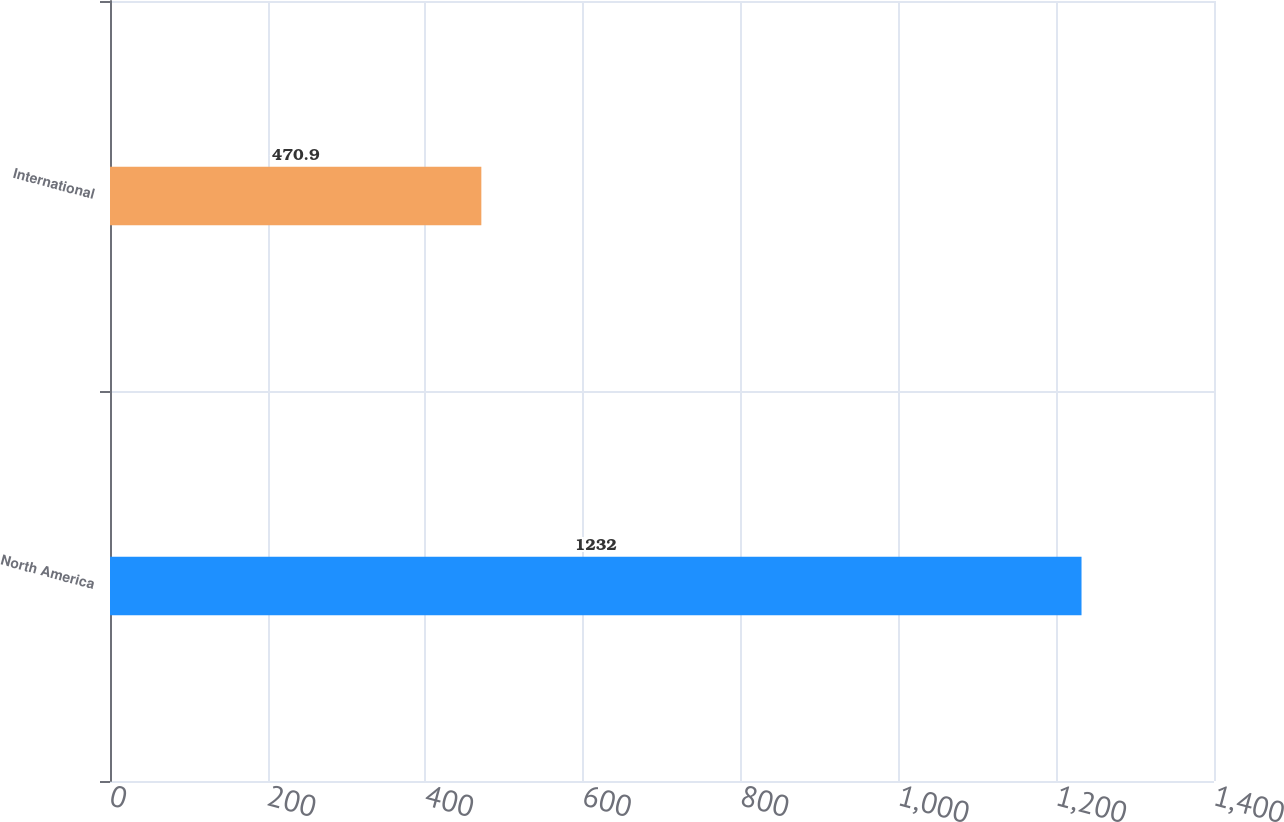Convert chart to OTSL. <chart><loc_0><loc_0><loc_500><loc_500><bar_chart><fcel>North America<fcel>International<nl><fcel>1232<fcel>470.9<nl></chart> 